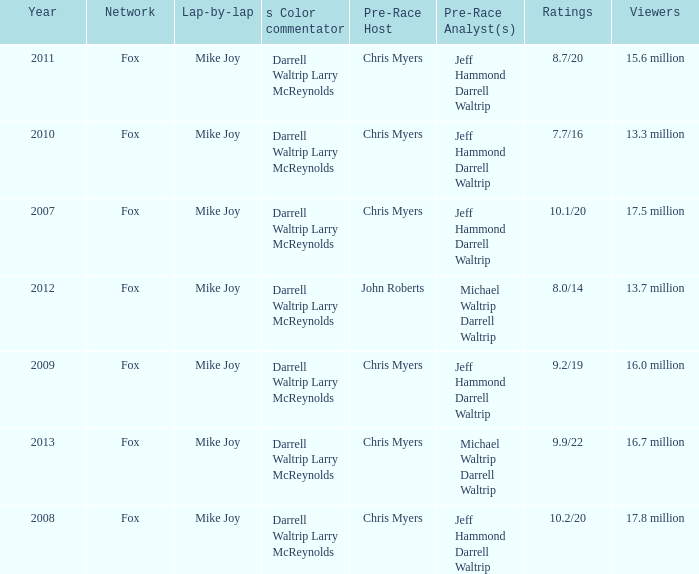Which Year is the lowest when the Viewers are 13.7 million? 2012.0. Would you be able to parse every entry in this table? {'header': ['Year', 'Network', 'Lap-by-lap', 's Color commentator', 'Pre-Race Host', 'Pre-Race Analyst(s)', 'Ratings', 'Viewers'], 'rows': [['2011', 'Fox', 'Mike Joy', 'Darrell Waltrip Larry McReynolds', 'Chris Myers', 'Jeff Hammond Darrell Waltrip', '8.7/20', '15.6 million'], ['2010', 'Fox', 'Mike Joy', 'Darrell Waltrip Larry McReynolds', 'Chris Myers', 'Jeff Hammond Darrell Waltrip', '7.7/16', '13.3 million'], ['2007', 'Fox', 'Mike Joy', 'Darrell Waltrip Larry McReynolds', 'Chris Myers', 'Jeff Hammond Darrell Waltrip', '10.1/20', '17.5 million'], ['2012', 'Fox', 'Mike Joy', 'Darrell Waltrip Larry McReynolds', 'John Roberts', 'Michael Waltrip Darrell Waltrip', '8.0/14', '13.7 million'], ['2009', 'Fox', 'Mike Joy', 'Darrell Waltrip Larry McReynolds', 'Chris Myers', 'Jeff Hammond Darrell Waltrip', '9.2/19', '16.0 million'], ['2013', 'Fox', 'Mike Joy', 'Darrell Waltrip Larry McReynolds', 'Chris Myers', 'Michael Waltrip Darrell Waltrip', '9.9/22', '16.7 million'], ['2008', 'Fox', 'Mike Joy', 'Darrell Waltrip Larry McReynolds', 'Chris Myers', 'Jeff Hammond Darrell Waltrip', '10.2/20', '17.8 million']]} 